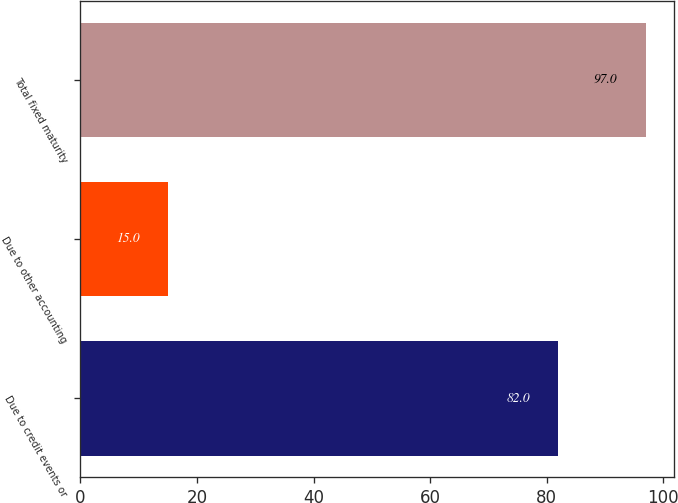Convert chart. <chart><loc_0><loc_0><loc_500><loc_500><bar_chart><fcel>Due to credit events or<fcel>Due to other accounting<fcel>Total fixed maturity<nl><fcel>82<fcel>15<fcel>97<nl></chart> 